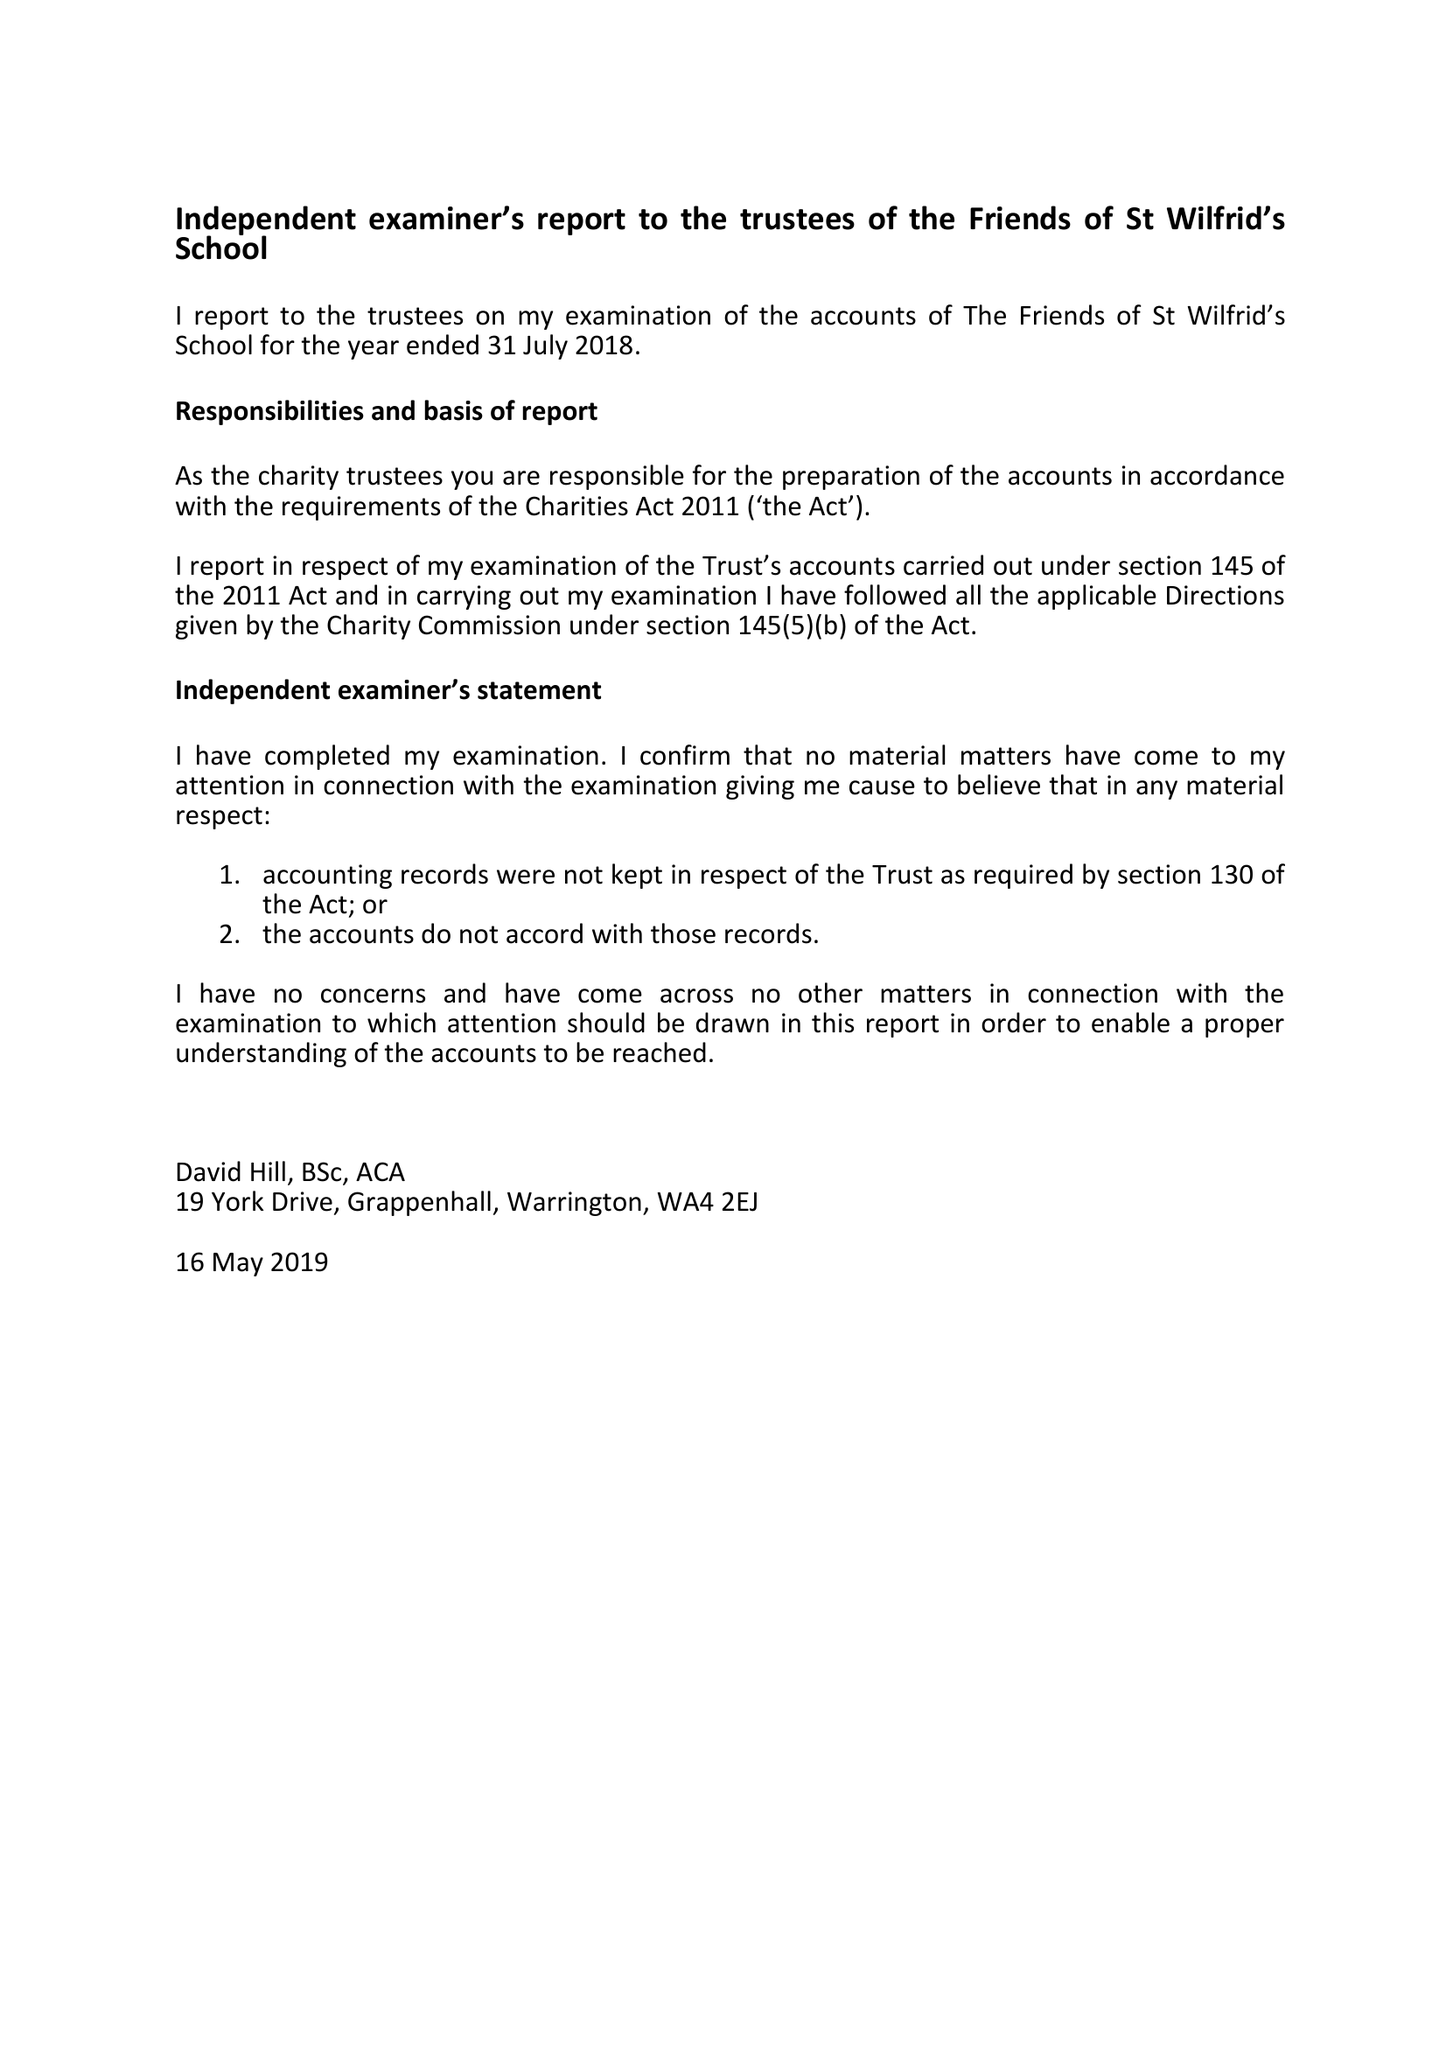What is the value for the charity_number?
Answer the question using a single word or phrase. 1122140 